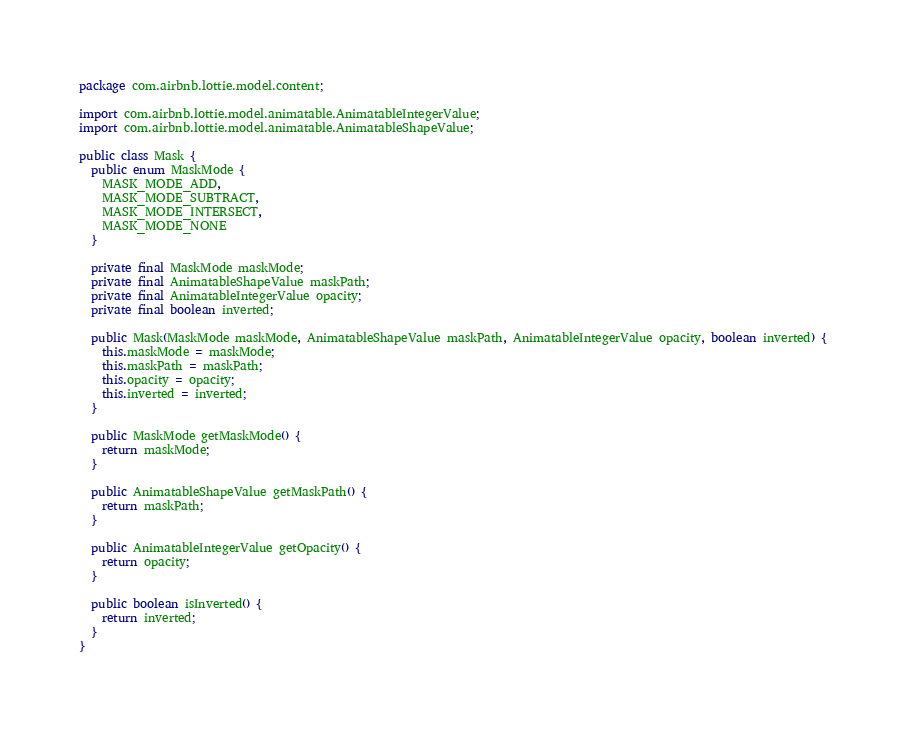<code> <loc_0><loc_0><loc_500><loc_500><_Java_>package com.airbnb.lottie.model.content;

import com.airbnb.lottie.model.animatable.AnimatableIntegerValue;
import com.airbnb.lottie.model.animatable.AnimatableShapeValue;

public class Mask {
  public enum MaskMode {
    MASK_MODE_ADD,
    MASK_MODE_SUBTRACT,
    MASK_MODE_INTERSECT,
    MASK_MODE_NONE
  }

  private final MaskMode maskMode;
  private final AnimatableShapeValue maskPath;
  private final AnimatableIntegerValue opacity;
  private final boolean inverted;

  public Mask(MaskMode maskMode, AnimatableShapeValue maskPath, AnimatableIntegerValue opacity, boolean inverted) {
    this.maskMode = maskMode;
    this.maskPath = maskPath;
    this.opacity = opacity;
    this.inverted = inverted;
  }

  public MaskMode getMaskMode() {
    return maskMode;
  }

  public AnimatableShapeValue getMaskPath() {
    return maskPath;
  }

  public AnimatableIntegerValue getOpacity() {
    return opacity;
  }

  public boolean isInverted() {
    return inverted;
  }
}
</code> 